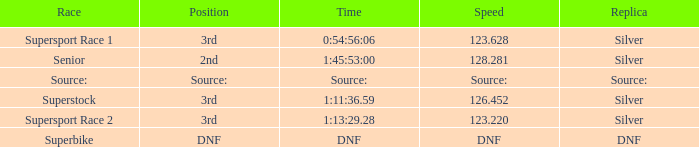Which race has a position of 3rd and a speed of 123.628? Supersport Race 1. 